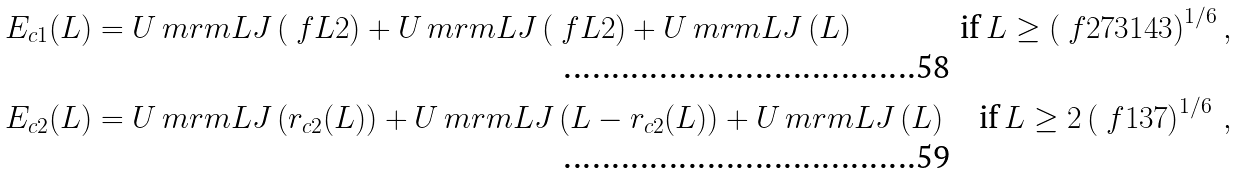Convert formula to latex. <formula><loc_0><loc_0><loc_500><loc_500>E _ { c 1 } ( L ) & = U _ { \ } m r m { L J } \left ( \ f { L } { 2 } \right ) + U _ { \ } m r m { L J } \left ( \ f { L } { 2 } \right ) + U _ { \ } m r m { L J } \left ( L \right ) \, & \text {if} \, L \geq \left ( \ f { 2 7 3 1 } { 4 3 } \right ) ^ { 1 / 6 } , \\ E _ { c 2 } ( L ) & = U _ { \ } m r m { L J } \left ( r _ { c 2 } ( L ) \right ) + U _ { \ } m r m { L J } \left ( L - r _ { c 2 } ( L ) \right ) + U _ { \ } m r m { L J } \left ( L \right ) & \text {if} \, L \geq 2 \left ( \ f { 1 3 } { 7 } \right ) ^ { 1 / 6 } \, ,</formula> 